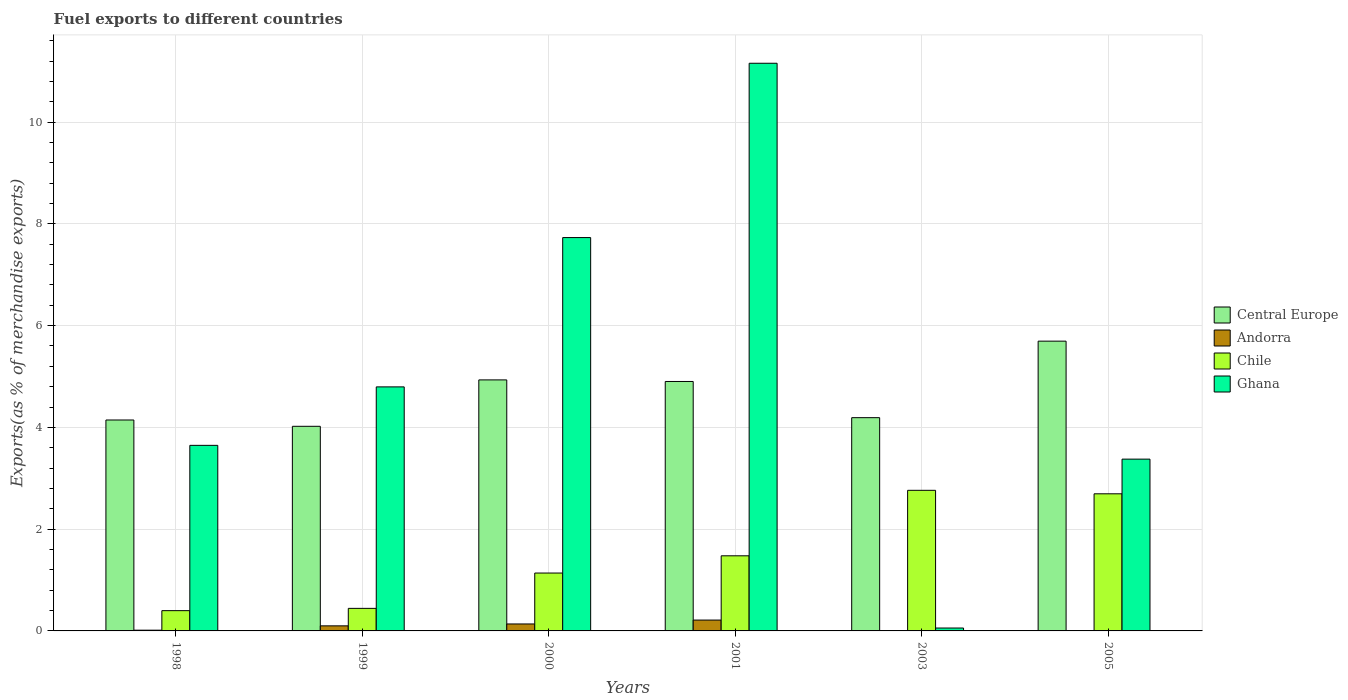How many different coloured bars are there?
Provide a short and direct response. 4. What is the label of the 2nd group of bars from the left?
Your response must be concise. 1999. What is the percentage of exports to different countries in Ghana in 2000?
Provide a succinct answer. 7.73. Across all years, what is the maximum percentage of exports to different countries in Andorra?
Give a very brief answer. 0.21. Across all years, what is the minimum percentage of exports to different countries in Andorra?
Your answer should be compact. 0. In which year was the percentage of exports to different countries in Chile minimum?
Your answer should be very brief. 1998. What is the total percentage of exports to different countries in Andorra in the graph?
Provide a short and direct response. 0.47. What is the difference between the percentage of exports to different countries in Central Europe in 1998 and that in 2005?
Offer a terse response. -1.55. What is the difference between the percentage of exports to different countries in Andorra in 2005 and the percentage of exports to different countries in Central Europe in 1998?
Offer a very short reply. -4.14. What is the average percentage of exports to different countries in Chile per year?
Keep it short and to the point. 1.49. In the year 1998, what is the difference between the percentage of exports to different countries in Ghana and percentage of exports to different countries in Chile?
Provide a succinct answer. 3.25. In how many years, is the percentage of exports to different countries in Ghana greater than 8.8 %?
Keep it short and to the point. 1. What is the ratio of the percentage of exports to different countries in Andorra in 1998 to that in 2001?
Your answer should be compact. 0.07. What is the difference between the highest and the second highest percentage of exports to different countries in Chile?
Your answer should be compact. 0.07. What is the difference between the highest and the lowest percentage of exports to different countries in Andorra?
Your answer should be very brief. 0.21. Is the sum of the percentage of exports to different countries in Central Europe in 2000 and 2003 greater than the maximum percentage of exports to different countries in Andorra across all years?
Make the answer very short. Yes. What does the 1st bar from the left in 2001 represents?
Offer a terse response. Central Europe. What does the 4th bar from the right in 2005 represents?
Provide a short and direct response. Central Europe. How many bars are there?
Your answer should be compact. 24. Are the values on the major ticks of Y-axis written in scientific E-notation?
Your answer should be compact. No. Does the graph contain grids?
Provide a succinct answer. Yes. What is the title of the graph?
Keep it short and to the point. Fuel exports to different countries. What is the label or title of the X-axis?
Your answer should be very brief. Years. What is the label or title of the Y-axis?
Offer a terse response. Exports(as % of merchandise exports). What is the Exports(as % of merchandise exports) in Central Europe in 1998?
Give a very brief answer. 4.15. What is the Exports(as % of merchandise exports) of Andorra in 1998?
Provide a succinct answer. 0.01. What is the Exports(as % of merchandise exports) of Chile in 1998?
Your response must be concise. 0.4. What is the Exports(as % of merchandise exports) of Ghana in 1998?
Offer a very short reply. 3.65. What is the Exports(as % of merchandise exports) of Central Europe in 1999?
Make the answer very short. 4.02. What is the Exports(as % of merchandise exports) of Andorra in 1999?
Provide a succinct answer. 0.1. What is the Exports(as % of merchandise exports) of Chile in 1999?
Provide a succinct answer. 0.44. What is the Exports(as % of merchandise exports) of Ghana in 1999?
Provide a succinct answer. 4.8. What is the Exports(as % of merchandise exports) in Central Europe in 2000?
Give a very brief answer. 4.93. What is the Exports(as % of merchandise exports) of Andorra in 2000?
Give a very brief answer. 0.14. What is the Exports(as % of merchandise exports) of Chile in 2000?
Your answer should be very brief. 1.14. What is the Exports(as % of merchandise exports) of Ghana in 2000?
Give a very brief answer. 7.73. What is the Exports(as % of merchandise exports) of Central Europe in 2001?
Your answer should be very brief. 4.9. What is the Exports(as % of merchandise exports) in Andorra in 2001?
Provide a succinct answer. 0.21. What is the Exports(as % of merchandise exports) in Chile in 2001?
Offer a terse response. 1.48. What is the Exports(as % of merchandise exports) in Ghana in 2001?
Offer a very short reply. 11.16. What is the Exports(as % of merchandise exports) in Central Europe in 2003?
Provide a succinct answer. 4.19. What is the Exports(as % of merchandise exports) of Andorra in 2003?
Keep it short and to the point. 0.01. What is the Exports(as % of merchandise exports) of Chile in 2003?
Keep it short and to the point. 2.76. What is the Exports(as % of merchandise exports) of Ghana in 2003?
Give a very brief answer. 0.06. What is the Exports(as % of merchandise exports) of Central Europe in 2005?
Your answer should be very brief. 5.69. What is the Exports(as % of merchandise exports) in Andorra in 2005?
Your answer should be compact. 0. What is the Exports(as % of merchandise exports) in Chile in 2005?
Your response must be concise. 2.69. What is the Exports(as % of merchandise exports) of Ghana in 2005?
Offer a very short reply. 3.38. Across all years, what is the maximum Exports(as % of merchandise exports) in Central Europe?
Your answer should be compact. 5.69. Across all years, what is the maximum Exports(as % of merchandise exports) of Andorra?
Provide a short and direct response. 0.21. Across all years, what is the maximum Exports(as % of merchandise exports) of Chile?
Your response must be concise. 2.76. Across all years, what is the maximum Exports(as % of merchandise exports) in Ghana?
Offer a very short reply. 11.16. Across all years, what is the minimum Exports(as % of merchandise exports) of Central Europe?
Keep it short and to the point. 4.02. Across all years, what is the minimum Exports(as % of merchandise exports) in Andorra?
Give a very brief answer. 0. Across all years, what is the minimum Exports(as % of merchandise exports) of Chile?
Your answer should be very brief. 0.4. Across all years, what is the minimum Exports(as % of merchandise exports) in Ghana?
Your response must be concise. 0.06. What is the total Exports(as % of merchandise exports) of Central Europe in the graph?
Provide a short and direct response. 27.89. What is the total Exports(as % of merchandise exports) of Andorra in the graph?
Give a very brief answer. 0.47. What is the total Exports(as % of merchandise exports) in Chile in the graph?
Keep it short and to the point. 8.91. What is the total Exports(as % of merchandise exports) of Ghana in the graph?
Make the answer very short. 30.76. What is the difference between the Exports(as % of merchandise exports) of Central Europe in 1998 and that in 1999?
Offer a terse response. 0.12. What is the difference between the Exports(as % of merchandise exports) in Andorra in 1998 and that in 1999?
Ensure brevity in your answer.  -0.09. What is the difference between the Exports(as % of merchandise exports) of Chile in 1998 and that in 1999?
Make the answer very short. -0.04. What is the difference between the Exports(as % of merchandise exports) of Ghana in 1998 and that in 1999?
Your answer should be very brief. -1.15. What is the difference between the Exports(as % of merchandise exports) in Central Europe in 1998 and that in 2000?
Offer a terse response. -0.79. What is the difference between the Exports(as % of merchandise exports) in Andorra in 1998 and that in 2000?
Provide a short and direct response. -0.12. What is the difference between the Exports(as % of merchandise exports) of Chile in 1998 and that in 2000?
Provide a short and direct response. -0.74. What is the difference between the Exports(as % of merchandise exports) in Ghana in 1998 and that in 2000?
Your answer should be very brief. -4.08. What is the difference between the Exports(as % of merchandise exports) of Central Europe in 1998 and that in 2001?
Provide a succinct answer. -0.76. What is the difference between the Exports(as % of merchandise exports) of Andorra in 1998 and that in 2001?
Make the answer very short. -0.2. What is the difference between the Exports(as % of merchandise exports) of Chile in 1998 and that in 2001?
Keep it short and to the point. -1.08. What is the difference between the Exports(as % of merchandise exports) in Ghana in 1998 and that in 2001?
Give a very brief answer. -7.51. What is the difference between the Exports(as % of merchandise exports) of Central Europe in 1998 and that in 2003?
Ensure brevity in your answer.  -0.05. What is the difference between the Exports(as % of merchandise exports) in Andorra in 1998 and that in 2003?
Your response must be concise. 0.01. What is the difference between the Exports(as % of merchandise exports) in Chile in 1998 and that in 2003?
Provide a short and direct response. -2.36. What is the difference between the Exports(as % of merchandise exports) in Ghana in 1998 and that in 2003?
Ensure brevity in your answer.  3.59. What is the difference between the Exports(as % of merchandise exports) in Central Europe in 1998 and that in 2005?
Offer a very short reply. -1.55. What is the difference between the Exports(as % of merchandise exports) in Andorra in 1998 and that in 2005?
Make the answer very short. 0.01. What is the difference between the Exports(as % of merchandise exports) of Chile in 1998 and that in 2005?
Your response must be concise. -2.3. What is the difference between the Exports(as % of merchandise exports) of Ghana in 1998 and that in 2005?
Keep it short and to the point. 0.27. What is the difference between the Exports(as % of merchandise exports) in Central Europe in 1999 and that in 2000?
Your response must be concise. -0.91. What is the difference between the Exports(as % of merchandise exports) of Andorra in 1999 and that in 2000?
Offer a terse response. -0.04. What is the difference between the Exports(as % of merchandise exports) of Chile in 1999 and that in 2000?
Your answer should be very brief. -0.69. What is the difference between the Exports(as % of merchandise exports) of Ghana in 1999 and that in 2000?
Your answer should be compact. -2.93. What is the difference between the Exports(as % of merchandise exports) of Central Europe in 1999 and that in 2001?
Your answer should be compact. -0.88. What is the difference between the Exports(as % of merchandise exports) in Andorra in 1999 and that in 2001?
Your answer should be very brief. -0.11. What is the difference between the Exports(as % of merchandise exports) in Chile in 1999 and that in 2001?
Provide a short and direct response. -1.03. What is the difference between the Exports(as % of merchandise exports) of Ghana in 1999 and that in 2001?
Keep it short and to the point. -6.36. What is the difference between the Exports(as % of merchandise exports) in Central Europe in 1999 and that in 2003?
Provide a succinct answer. -0.17. What is the difference between the Exports(as % of merchandise exports) of Andorra in 1999 and that in 2003?
Give a very brief answer. 0.09. What is the difference between the Exports(as % of merchandise exports) in Chile in 1999 and that in 2003?
Offer a terse response. -2.32. What is the difference between the Exports(as % of merchandise exports) in Ghana in 1999 and that in 2003?
Your answer should be compact. 4.74. What is the difference between the Exports(as % of merchandise exports) of Central Europe in 1999 and that in 2005?
Ensure brevity in your answer.  -1.67. What is the difference between the Exports(as % of merchandise exports) in Andorra in 1999 and that in 2005?
Offer a very short reply. 0.1. What is the difference between the Exports(as % of merchandise exports) in Chile in 1999 and that in 2005?
Provide a succinct answer. -2.25. What is the difference between the Exports(as % of merchandise exports) in Ghana in 1999 and that in 2005?
Provide a succinct answer. 1.42. What is the difference between the Exports(as % of merchandise exports) of Central Europe in 2000 and that in 2001?
Your response must be concise. 0.03. What is the difference between the Exports(as % of merchandise exports) in Andorra in 2000 and that in 2001?
Ensure brevity in your answer.  -0.08. What is the difference between the Exports(as % of merchandise exports) of Chile in 2000 and that in 2001?
Keep it short and to the point. -0.34. What is the difference between the Exports(as % of merchandise exports) of Ghana in 2000 and that in 2001?
Offer a very short reply. -3.43. What is the difference between the Exports(as % of merchandise exports) of Central Europe in 2000 and that in 2003?
Offer a very short reply. 0.74. What is the difference between the Exports(as % of merchandise exports) of Andorra in 2000 and that in 2003?
Ensure brevity in your answer.  0.13. What is the difference between the Exports(as % of merchandise exports) of Chile in 2000 and that in 2003?
Provide a short and direct response. -1.63. What is the difference between the Exports(as % of merchandise exports) of Ghana in 2000 and that in 2003?
Provide a short and direct response. 7.67. What is the difference between the Exports(as % of merchandise exports) of Central Europe in 2000 and that in 2005?
Your answer should be compact. -0.76. What is the difference between the Exports(as % of merchandise exports) in Andorra in 2000 and that in 2005?
Make the answer very short. 0.13. What is the difference between the Exports(as % of merchandise exports) in Chile in 2000 and that in 2005?
Offer a terse response. -1.56. What is the difference between the Exports(as % of merchandise exports) of Ghana in 2000 and that in 2005?
Give a very brief answer. 4.35. What is the difference between the Exports(as % of merchandise exports) in Central Europe in 2001 and that in 2003?
Your answer should be compact. 0.71. What is the difference between the Exports(as % of merchandise exports) of Andorra in 2001 and that in 2003?
Provide a short and direct response. 0.21. What is the difference between the Exports(as % of merchandise exports) in Chile in 2001 and that in 2003?
Offer a terse response. -1.29. What is the difference between the Exports(as % of merchandise exports) in Ghana in 2001 and that in 2003?
Provide a short and direct response. 11.1. What is the difference between the Exports(as % of merchandise exports) in Central Europe in 2001 and that in 2005?
Give a very brief answer. -0.79. What is the difference between the Exports(as % of merchandise exports) in Andorra in 2001 and that in 2005?
Keep it short and to the point. 0.21. What is the difference between the Exports(as % of merchandise exports) in Chile in 2001 and that in 2005?
Your answer should be compact. -1.22. What is the difference between the Exports(as % of merchandise exports) of Ghana in 2001 and that in 2005?
Offer a terse response. 7.78. What is the difference between the Exports(as % of merchandise exports) in Central Europe in 2003 and that in 2005?
Offer a terse response. -1.5. What is the difference between the Exports(as % of merchandise exports) in Andorra in 2003 and that in 2005?
Provide a short and direct response. 0. What is the difference between the Exports(as % of merchandise exports) of Chile in 2003 and that in 2005?
Keep it short and to the point. 0.07. What is the difference between the Exports(as % of merchandise exports) in Ghana in 2003 and that in 2005?
Provide a succinct answer. -3.32. What is the difference between the Exports(as % of merchandise exports) in Central Europe in 1998 and the Exports(as % of merchandise exports) in Andorra in 1999?
Offer a very short reply. 4.05. What is the difference between the Exports(as % of merchandise exports) in Central Europe in 1998 and the Exports(as % of merchandise exports) in Chile in 1999?
Provide a short and direct response. 3.7. What is the difference between the Exports(as % of merchandise exports) of Central Europe in 1998 and the Exports(as % of merchandise exports) of Ghana in 1999?
Provide a succinct answer. -0.65. What is the difference between the Exports(as % of merchandise exports) in Andorra in 1998 and the Exports(as % of merchandise exports) in Chile in 1999?
Your answer should be very brief. -0.43. What is the difference between the Exports(as % of merchandise exports) in Andorra in 1998 and the Exports(as % of merchandise exports) in Ghana in 1999?
Provide a succinct answer. -4.78. What is the difference between the Exports(as % of merchandise exports) of Chile in 1998 and the Exports(as % of merchandise exports) of Ghana in 1999?
Make the answer very short. -4.4. What is the difference between the Exports(as % of merchandise exports) in Central Europe in 1998 and the Exports(as % of merchandise exports) in Andorra in 2000?
Make the answer very short. 4.01. What is the difference between the Exports(as % of merchandise exports) of Central Europe in 1998 and the Exports(as % of merchandise exports) of Chile in 2000?
Your answer should be very brief. 3.01. What is the difference between the Exports(as % of merchandise exports) of Central Europe in 1998 and the Exports(as % of merchandise exports) of Ghana in 2000?
Your answer should be compact. -3.58. What is the difference between the Exports(as % of merchandise exports) of Andorra in 1998 and the Exports(as % of merchandise exports) of Chile in 2000?
Keep it short and to the point. -1.12. What is the difference between the Exports(as % of merchandise exports) of Andorra in 1998 and the Exports(as % of merchandise exports) of Ghana in 2000?
Offer a very short reply. -7.72. What is the difference between the Exports(as % of merchandise exports) of Chile in 1998 and the Exports(as % of merchandise exports) of Ghana in 2000?
Give a very brief answer. -7.33. What is the difference between the Exports(as % of merchandise exports) of Central Europe in 1998 and the Exports(as % of merchandise exports) of Andorra in 2001?
Offer a terse response. 3.93. What is the difference between the Exports(as % of merchandise exports) of Central Europe in 1998 and the Exports(as % of merchandise exports) of Chile in 2001?
Give a very brief answer. 2.67. What is the difference between the Exports(as % of merchandise exports) in Central Europe in 1998 and the Exports(as % of merchandise exports) in Ghana in 2001?
Offer a very short reply. -7.01. What is the difference between the Exports(as % of merchandise exports) of Andorra in 1998 and the Exports(as % of merchandise exports) of Chile in 2001?
Give a very brief answer. -1.46. What is the difference between the Exports(as % of merchandise exports) of Andorra in 1998 and the Exports(as % of merchandise exports) of Ghana in 2001?
Ensure brevity in your answer.  -11.14. What is the difference between the Exports(as % of merchandise exports) in Chile in 1998 and the Exports(as % of merchandise exports) in Ghana in 2001?
Your answer should be very brief. -10.76. What is the difference between the Exports(as % of merchandise exports) of Central Europe in 1998 and the Exports(as % of merchandise exports) of Andorra in 2003?
Ensure brevity in your answer.  4.14. What is the difference between the Exports(as % of merchandise exports) of Central Europe in 1998 and the Exports(as % of merchandise exports) of Chile in 2003?
Provide a short and direct response. 1.38. What is the difference between the Exports(as % of merchandise exports) of Central Europe in 1998 and the Exports(as % of merchandise exports) of Ghana in 2003?
Make the answer very short. 4.09. What is the difference between the Exports(as % of merchandise exports) of Andorra in 1998 and the Exports(as % of merchandise exports) of Chile in 2003?
Your answer should be very brief. -2.75. What is the difference between the Exports(as % of merchandise exports) in Andorra in 1998 and the Exports(as % of merchandise exports) in Ghana in 2003?
Your answer should be very brief. -0.04. What is the difference between the Exports(as % of merchandise exports) in Chile in 1998 and the Exports(as % of merchandise exports) in Ghana in 2003?
Your answer should be compact. 0.34. What is the difference between the Exports(as % of merchandise exports) of Central Europe in 1998 and the Exports(as % of merchandise exports) of Andorra in 2005?
Your answer should be very brief. 4.14. What is the difference between the Exports(as % of merchandise exports) in Central Europe in 1998 and the Exports(as % of merchandise exports) in Chile in 2005?
Offer a terse response. 1.45. What is the difference between the Exports(as % of merchandise exports) of Central Europe in 1998 and the Exports(as % of merchandise exports) of Ghana in 2005?
Your answer should be very brief. 0.77. What is the difference between the Exports(as % of merchandise exports) in Andorra in 1998 and the Exports(as % of merchandise exports) in Chile in 2005?
Ensure brevity in your answer.  -2.68. What is the difference between the Exports(as % of merchandise exports) of Andorra in 1998 and the Exports(as % of merchandise exports) of Ghana in 2005?
Keep it short and to the point. -3.36. What is the difference between the Exports(as % of merchandise exports) of Chile in 1998 and the Exports(as % of merchandise exports) of Ghana in 2005?
Make the answer very short. -2.98. What is the difference between the Exports(as % of merchandise exports) in Central Europe in 1999 and the Exports(as % of merchandise exports) in Andorra in 2000?
Offer a terse response. 3.88. What is the difference between the Exports(as % of merchandise exports) of Central Europe in 1999 and the Exports(as % of merchandise exports) of Chile in 2000?
Make the answer very short. 2.88. What is the difference between the Exports(as % of merchandise exports) of Central Europe in 1999 and the Exports(as % of merchandise exports) of Ghana in 2000?
Offer a very short reply. -3.71. What is the difference between the Exports(as % of merchandise exports) in Andorra in 1999 and the Exports(as % of merchandise exports) in Chile in 2000?
Provide a short and direct response. -1.04. What is the difference between the Exports(as % of merchandise exports) of Andorra in 1999 and the Exports(as % of merchandise exports) of Ghana in 2000?
Your response must be concise. -7.63. What is the difference between the Exports(as % of merchandise exports) in Chile in 1999 and the Exports(as % of merchandise exports) in Ghana in 2000?
Provide a short and direct response. -7.29. What is the difference between the Exports(as % of merchandise exports) in Central Europe in 1999 and the Exports(as % of merchandise exports) in Andorra in 2001?
Your response must be concise. 3.81. What is the difference between the Exports(as % of merchandise exports) of Central Europe in 1999 and the Exports(as % of merchandise exports) of Chile in 2001?
Your answer should be very brief. 2.54. What is the difference between the Exports(as % of merchandise exports) of Central Europe in 1999 and the Exports(as % of merchandise exports) of Ghana in 2001?
Your answer should be compact. -7.13. What is the difference between the Exports(as % of merchandise exports) in Andorra in 1999 and the Exports(as % of merchandise exports) in Chile in 2001?
Your answer should be compact. -1.38. What is the difference between the Exports(as % of merchandise exports) in Andorra in 1999 and the Exports(as % of merchandise exports) in Ghana in 2001?
Give a very brief answer. -11.06. What is the difference between the Exports(as % of merchandise exports) of Chile in 1999 and the Exports(as % of merchandise exports) of Ghana in 2001?
Provide a succinct answer. -10.71. What is the difference between the Exports(as % of merchandise exports) in Central Europe in 1999 and the Exports(as % of merchandise exports) in Andorra in 2003?
Offer a very short reply. 4.01. What is the difference between the Exports(as % of merchandise exports) in Central Europe in 1999 and the Exports(as % of merchandise exports) in Chile in 2003?
Provide a succinct answer. 1.26. What is the difference between the Exports(as % of merchandise exports) of Central Europe in 1999 and the Exports(as % of merchandise exports) of Ghana in 2003?
Ensure brevity in your answer.  3.96. What is the difference between the Exports(as % of merchandise exports) of Andorra in 1999 and the Exports(as % of merchandise exports) of Chile in 2003?
Keep it short and to the point. -2.66. What is the difference between the Exports(as % of merchandise exports) of Andorra in 1999 and the Exports(as % of merchandise exports) of Ghana in 2003?
Your response must be concise. 0.04. What is the difference between the Exports(as % of merchandise exports) in Chile in 1999 and the Exports(as % of merchandise exports) in Ghana in 2003?
Your answer should be compact. 0.39. What is the difference between the Exports(as % of merchandise exports) in Central Europe in 1999 and the Exports(as % of merchandise exports) in Andorra in 2005?
Your response must be concise. 4.02. What is the difference between the Exports(as % of merchandise exports) in Central Europe in 1999 and the Exports(as % of merchandise exports) in Chile in 2005?
Your response must be concise. 1.33. What is the difference between the Exports(as % of merchandise exports) of Central Europe in 1999 and the Exports(as % of merchandise exports) of Ghana in 2005?
Ensure brevity in your answer.  0.65. What is the difference between the Exports(as % of merchandise exports) in Andorra in 1999 and the Exports(as % of merchandise exports) in Chile in 2005?
Your answer should be very brief. -2.6. What is the difference between the Exports(as % of merchandise exports) in Andorra in 1999 and the Exports(as % of merchandise exports) in Ghana in 2005?
Your answer should be very brief. -3.28. What is the difference between the Exports(as % of merchandise exports) in Chile in 1999 and the Exports(as % of merchandise exports) in Ghana in 2005?
Offer a very short reply. -2.93. What is the difference between the Exports(as % of merchandise exports) of Central Europe in 2000 and the Exports(as % of merchandise exports) of Andorra in 2001?
Make the answer very short. 4.72. What is the difference between the Exports(as % of merchandise exports) in Central Europe in 2000 and the Exports(as % of merchandise exports) in Chile in 2001?
Your answer should be compact. 3.46. What is the difference between the Exports(as % of merchandise exports) in Central Europe in 2000 and the Exports(as % of merchandise exports) in Ghana in 2001?
Keep it short and to the point. -6.22. What is the difference between the Exports(as % of merchandise exports) of Andorra in 2000 and the Exports(as % of merchandise exports) of Chile in 2001?
Your answer should be very brief. -1.34. What is the difference between the Exports(as % of merchandise exports) in Andorra in 2000 and the Exports(as % of merchandise exports) in Ghana in 2001?
Give a very brief answer. -11.02. What is the difference between the Exports(as % of merchandise exports) in Chile in 2000 and the Exports(as % of merchandise exports) in Ghana in 2001?
Offer a terse response. -10.02. What is the difference between the Exports(as % of merchandise exports) of Central Europe in 2000 and the Exports(as % of merchandise exports) of Andorra in 2003?
Offer a terse response. 4.93. What is the difference between the Exports(as % of merchandise exports) in Central Europe in 2000 and the Exports(as % of merchandise exports) in Chile in 2003?
Your answer should be compact. 2.17. What is the difference between the Exports(as % of merchandise exports) of Central Europe in 2000 and the Exports(as % of merchandise exports) of Ghana in 2003?
Offer a terse response. 4.88. What is the difference between the Exports(as % of merchandise exports) in Andorra in 2000 and the Exports(as % of merchandise exports) in Chile in 2003?
Keep it short and to the point. -2.63. What is the difference between the Exports(as % of merchandise exports) in Andorra in 2000 and the Exports(as % of merchandise exports) in Ghana in 2003?
Your response must be concise. 0.08. What is the difference between the Exports(as % of merchandise exports) of Chile in 2000 and the Exports(as % of merchandise exports) of Ghana in 2003?
Provide a short and direct response. 1.08. What is the difference between the Exports(as % of merchandise exports) in Central Europe in 2000 and the Exports(as % of merchandise exports) in Andorra in 2005?
Offer a very short reply. 4.93. What is the difference between the Exports(as % of merchandise exports) in Central Europe in 2000 and the Exports(as % of merchandise exports) in Chile in 2005?
Offer a very short reply. 2.24. What is the difference between the Exports(as % of merchandise exports) of Central Europe in 2000 and the Exports(as % of merchandise exports) of Ghana in 2005?
Provide a short and direct response. 1.56. What is the difference between the Exports(as % of merchandise exports) of Andorra in 2000 and the Exports(as % of merchandise exports) of Chile in 2005?
Your answer should be compact. -2.56. What is the difference between the Exports(as % of merchandise exports) of Andorra in 2000 and the Exports(as % of merchandise exports) of Ghana in 2005?
Your response must be concise. -3.24. What is the difference between the Exports(as % of merchandise exports) in Chile in 2000 and the Exports(as % of merchandise exports) in Ghana in 2005?
Your response must be concise. -2.24. What is the difference between the Exports(as % of merchandise exports) in Central Europe in 2001 and the Exports(as % of merchandise exports) in Andorra in 2003?
Provide a succinct answer. 4.9. What is the difference between the Exports(as % of merchandise exports) of Central Europe in 2001 and the Exports(as % of merchandise exports) of Chile in 2003?
Your answer should be compact. 2.14. What is the difference between the Exports(as % of merchandise exports) in Central Europe in 2001 and the Exports(as % of merchandise exports) in Ghana in 2003?
Keep it short and to the point. 4.85. What is the difference between the Exports(as % of merchandise exports) of Andorra in 2001 and the Exports(as % of merchandise exports) of Chile in 2003?
Ensure brevity in your answer.  -2.55. What is the difference between the Exports(as % of merchandise exports) of Andorra in 2001 and the Exports(as % of merchandise exports) of Ghana in 2003?
Your response must be concise. 0.16. What is the difference between the Exports(as % of merchandise exports) in Chile in 2001 and the Exports(as % of merchandise exports) in Ghana in 2003?
Give a very brief answer. 1.42. What is the difference between the Exports(as % of merchandise exports) in Central Europe in 2001 and the Exports(as % of merchandise exports) in Andorra in 2005?
Offer a terse response. 4.9. What is the difference between the Exports(as % of merchandise exports) in Central Europe in 2001 and the Exports(as % of merchandise exports) in Chile in 2005?
Give a very brief answer. 2.21. What is the difference between the Exports(as % of merchandise exports) of Central Europe in 2001 and the Exports(as % of merchandise exports) of Ghana in 2005?
Offer a very short reply. 1.53. What is the difference between the Exports(as % of merchandise exports) of Andorra in 2001 and the Exports(as % of merchandise exports) of Chile in 2005?
Provide a succinct answer. -2.48. What is the difference between the Exports(as % of merchandise exports) in Andorra in 2001 and the Exports(as % of merchandise exports) in Ghana in 2005?
Your answer should be compact. -3.16. What is the difference between the Exports(as % of merchandise exports) in Chile in 2001 and the Exports(as % of merchandise exports) in Ghana in 2005?
Offer a very short reply. -1.9. What is the difference between the Exports(as % of merchandise exports) in Central Europe in 2003 and the Exports(as % of merchandise exports) in Andorra in 2005?
Your response must be concise. 4.19. What is the difference between the Exports(as % of merchandise exports) of Central Europe in 2003 and the Exports(as % of merchandise exports) of Chile in 2005?
Provide a short and direct response. 1.5. What is the difference between the Exports(as % of merchandise exports) in Central Europe in 2003 and the Exports(as % of merchandise exports) in Ghana in 2005?
Your answer should be very brief. 0.81. What is the difference between the Exports(as % of merchandise exports) in Andorra in 2003 and the Exports(as % of merchandise exports) in Chile in 2005?
Your response must be concise. -2.69. What is the difference between the Exports(as % of merchandise exports) in Andorra in 2003 and the Exports(as % of merchandise exports) in Ghana in 2005?
Your response must be concise. -3.37. What is the difference between the Exports(as % of merchandise exports) of Chile in 2003 and the Exports(as % of merchandise exports) of Ghana in 2005?
Make the answer very short. -0.61. What is the average Exports(as % of merchandise exports) in Central Europe per year?
Offer a terse response. 4.65. What is the average Exports(as % of merchandise exports) of Andorra per year?
Provide a short and direct response. 0.08. What is the average Exports(as % of merchandise exports) in Chile per year?
Make the answer very short. 1.49. What is the average Exports(as % of merchandise exports) of Ghana per year?
Ensure brevity in your answer.  5.13. In the year 1998, what is the difference between the Exports(as % of merchandise exports) of Central Europe and Exports(as % of merchandise exports) of Andorra?
Provide a succinct answer. 4.13. In the year 1998, what is the difference between the Exports(as % of merchandise exports) of Central Europe and Exports(as % of merchandise exports) of Chile?
Offer a very short reply. 3.75. In the year 1998, what is the difference between the Exports(as % of merchandise exports) in Central Europe and Exports(as % of merchandise exports) in Ghana?
Make the answer very short. 0.5. In the year 1998, what is the difference between the Exports(as % of merchandise exports) in Andorra and Exports(as % of merchandise exports) in Chile?
Your answer should be compact. -0.38. In the year 1998, what is the difference between the Exports(as % of merchandise exports) of Andorra and Exports(as % of merchandise exports) of Ghana?
Provide a succinct answer. -3.63. In the year 1998, what is the difference between the Exports(as % of merchandise exports) of Chile and Exports(as % of merchandise exports) of Ghana?
Offer a terse response. -3.25. In the year 1999, what is the difference between the Exports(as % of merchandise exports) of Central Europe and Exports(as % of merchandise exports) of Andorra?
Your response must be concise. 3.92. In the year 1999, what is the difference between the Exports(as % of merchandise exports) of Central Europe and Exports(as % of merchandise exports) of Chile?
Your answer should be compact. 3.58. In the year 1999, what is the difference between the Exports(as % of merchandise exports) in Central Europe and Exports(as % of merchandise exports) in Ghana?
Provide a succinct answer. -0.77. In the year 1999, what is the difference between the Exports(as % of merchandise exports) in Andorra and Exports(as % of merchandise exports) in Chile?
Ensure brevity in your answer.  -0.34. In the year 1999, what is the difference between the Exports(as % of merchandise exports) in Andorra and Exports(as % of merchandise exports) in Ghana?
Keep it short and to the point. -4.7. In the year 1999, what is the difference between the Exports(as % of merchandise exports) in Chile and Exports(as % of merchandise exports) in Ghana?
Your response must be concise. -4.35. In the year 2000, what is the difference between the Exports(as % of merchandise exports) in Central Europe and Exports(as % of merchandise exports) in Andorra?
Your response must be concise. 4.8. In the year 2000, what is the difference between the Exports(as % of merchandise exports) of Central Europe and Exports(as % of merchandise exports) of Chile?
Keep it short and to the point. 3.8. In the year 2000, what is the difference between the Exports(as % of merchandise exports) of Central Europe and Exports(as % of merchandise exports) of Ghana?
Ensure brevity in your answer.  -2.8. In the year 2000, what is the difference between the Exports(as % of merchandise exports) of Andorra and Exports(as % of merchandise exports) of Chile?
Provide a succinct answer. -1. In the year 2000, what is the difference between the Exports(as % of merchandise exports) in Andorra and Exports(as % of merchandise exports) in Ghana?
Offer a very short reply. -7.59. In the year 2000, what is the difference between the Exports(as % of merchandise exports) of Chile and Exports(as % of merchandise exports) of Ghana?
Provide a succinct answer. -6.59. In the year 2001, what is the difference between the Exports(as % of merchandise exports) in Central Europe and Exports(as % of merchandise exports) in Andorra?
Make the answer very short. 4.69. In the year 2001, what is the difference between the Exports(as % of merchandise exports) in Central Europe and Exports(as % of merchandise exports) in Chile?
Provide a short and direct response. 3.43. In the year 2001, what is the difference between the Exports(as % of merchandise exports) of Central Europe and Exports(as % of merchandise exports) of Ghana?
Offer a very short reply. -6.25. In the year 2001, what is the difference between the Exports(as % of merchandise exports) in Andorra and Exports(as % of merchandise exports) in Chile?
Make the answer very short. -1.26. In the year 2001, what is the difference between the Exports(as % of merchandise exports) of Andorra and Exports(as % of merchandise exports) of Ghana?
Make the answer very short. -10.94. In the year 2001, what is the difference between the Exports(as % of merchandise exports) in Chile and Exports(as % of merchandise exports) in Ghana?
Offer a very short reply. -9.68. In the year 2003, what is the difference between the Exports(as % of merchandise exports) in Central Europe and Exports(as % of merchandise exports) in Andorra?
Provide a succinct answer. 4.18. In the year 2003, what is the difference between the Exports(as % of merchandise exports) of Central Europe and Exports(as % of merchandise exports) of Chile?
Offer a very short reply. 1.43. In the year 2003, what is the difference between the Exports(as % of merchandise exports) of Central Europe and Exports(as % of merchandise exports) of Ghana?
Make the answer very short. 4.13. In the year 2003, what is the difference between the Exports(as % of merchandise exports) of Andorra and Exports(as % of merchandise exports) of Chile?
Your response must be concise. -2.76. In the year 2003, what is the difference between the Exports(as % of merchandise exports) of Andorra and Exports(as % of merchandise exports) of Ghana?
Keep it short and to the point. -0.05. In the year 2003, what is the difference between the Exports(as % of merchandise exports) of Chile and Exports(as % of merchandise exports) of Ghana?
Give a very brief answer. 2.71. In the year 2005, what is the difference between the Exports(as % of merchandise exports) of Central Europe and Exports(as % of merchandise exports) of Andorra?
Provide a succinct answer. 5.69. In the year 2005, what is the difference between the Exports(as % of merchandise exports) in Central Europe and Exports(as % of merchandise exports) in Chile?
Offer a very short reply. 3. In the year 2005, what is the difference between the Exports(as % of merchandise exports) in Central Europe and Exports(as % of merchandise exports) in Ghana?
Provide a succinct answer. 2.32. In the year 2005, what is the difference between the Exports(as % of merchandise exports) in Andorra and Exports(as % of merchandise exports) in Chile?
Your answer should be very brief. -2.69. In the year 2005, what is the difference between the Exports(as % of merchandise exports) in Andorra and Exports(as % of merchandise exports) in Ghana?
Ensure brevity in your answer.  -3.37. In the year 2005, what is the difference between the Exports(as % of merchandise exports) in Chile and Exports(as % of merchandise exports) in Ghana?
Keep it short and to the point. -0.68. What is the ratio of the Exports(as % of merchandise exports) in Central Europe in 1998 to that in 1999?
Your answer should be compact. 1.03. What is the ratio of the Exports(as % of merchandise exports) of Andorra in 1998 to that in 1999?
Your answer should be compact. 0.15. What is the ratio of the Exports(as % of merchandise exports) of Chile in 1998 to that in 1999?
Provide a short and direct response. 0.9. What is the ratio of the Exports(as % of merchandise exports) in Ghana in 1998 to that in 1999?
Provide a succinct answer. 0.76. What is the ratio of the Exports(as % of merchandise exports) in Central Europe in 1998 to that in 2000?
Provide a short and direct response. 0.84. What is the ratio of the Exports(as % of merchandise exports) of Andorra in 1998 to that in 2000?
Provide a short and direct response. 0.11. What is the ratio of the Exports(as % of merchandise exports) in Chile in 1998 to that in 2000?
Your answer should be compact. 0.35. What is the ratio of the Exports(as % of merchandise exports) of Ghana in 1998 to that in 2000?
Give a very brief answer. 0.47. What is the ratio of the Exports(as % of merchandise exports) in Central Europe in 1998 to that in 2001?
Your answer should be compact. 0.85. What is the ratio of the Exports(as % of merchandise exports) of Andorra in 1998 to that in 2001?
Keep it short and to the point. 0.07. What is the ratio of the Exports(as % of merchandise exports) of Chile in 1998 to that in 2001?
Give a very brief answer. 0.27. What is the ratio of the Exports(as % of merchandise exports) of Ghana in 1998 to that in 2001?
Keep it short and to the point. 0.33. What is the ratio of the Exports(as % of merchandise exports) of Central Europe in 1998 to that in 2003?
Give a very brief answer. 0.99. What is the ratio of the Exports(as % of merchandise exports) of Andorra in 1998 to that in 2003?
Your response must be concise. 2.19. What is the ratio of the Exports(as % of merchandise exports) of Chile in 1998 to that in 2003?
Give a very brief answer. 0.14. What is the ratio of the Exports(as % of merchandise exports) in Ghana in 1998 to that in 2003?
Ensure brevity in your answer.  64.13. What is the ratio of the Exports(as % of merchandise exports) in Central Europe in 1998 to that in 2005?
Keep it short and to the point. 0.73. What is the ratio of the Exports(as % of merchandise exports) of Andorra in 1998 to that in 2005?
Ensure brevity in your answer.  7.3. What is the ratio of the Exports(as % of merchandise exports) in Chile in 1998 to that in 2005?
Keep it short and to the point. 0.15. What is the ratio of the Exports(as % of merchandise exports) of Ghana in 1998 to that in 2005?
Your answer should be very brief. 1.08. What is the ratio of the Exports(as % of merchandise exports) in Central Europe in 1999 to that in 2000?
Offer a very short reply. 0.82. What is the ratio of the Exports(as % of merchandise exports) of Andorra in 1999 to that in 2000?
Offer a very short reply. 0.73. What is the ratio of the Exports(as % of merchandise exports) of Chile in 1999 to that in 2000?
Keep it short and to the point. 0.39. What is the ratio of the Exports(as % of merchandise exports) of Ghana in 1999 to that in 2000?
Provide a short and direct response. 0.62. What is the ratio of the Exports(as % of merchandise exports) of Central Europe in 1999 to that in 2001?
Offer a terse response. 0.82. What is the ratio of the Exports(as % of merchandise exports) of Andorra in 1999 to that in 2001?
Provide a short and direct response. 0.47. What is the ratio of the Exports(as % of merchandise exports) of Chile in 1999 to that in 2001?
Provide a succinct answer. 0.3. What is the ratio of the Exports(as % of merchandise exports) in Ghana in 1999 to that in 2001?
Provide a succinct answer. 0.43. What is the ratio of the Exports(as % of merchandise exports) in Central Europe in 1999 to that in 2003?
Your answer should be very brief. 0.96. What is the ratio of the Exports(as % of merchandise exports) of Andorra in 1999 to that in 2003?
Ensure brevity in your answer.  15.06. What is the ratio of the Exports(as % of merchandise exports) in Chile in 1999 to that in 2003?
Your answer should be very brief. 0.16. What is the ratio of the Exports(as % of merchandise exports) of Ghana in 1999 to that in 2003?
Offer a terse response. 84.33. What is the ratio of the Exports(as % of merchandise exports) in Central Europe in 1999 to that in 2005?
Offer a terse response. 0.71. What is the ratio of the Exports(as % of merchandise exports) in Andorra in 1999 to that in 2005?
Keep it short and to the point. 50.27. What is the ratio of the Exports(as % of merchandise exports) in Chile in 1999 to that in 2005?
Ensure brevity in your answer.  0.16. What is the ratio of the Exports(as % of merchandise exports) in Ghana in 1999 to that in 2005?
Give a very brief answer. 1.42. What is the ratio of the Exports(as % of merchandise exports) in Central Europe in 2000 to that in 2001?
Provide a short and direct response. 1.01. What is the ratio of the Exports(as % of merchandise exports) of Andorra in 2000 to that in 2001?
Ensure brevity in your answer.  0.64. What is the ratio of the Exports(as % of merchandise exports) of Chile in 2000 to that in 2001?
Ensure brevity in your answer.  0.77. What is the ratio of the Exports(as % of merchandise exports) of Ghana in 2000 to that in 2001?
Provide a succinct answer. 0.69. What is the ratio of the Exports(as % of merchandise exports) of Central Europe in 2000 to that in 2003?
Your answer should be very brief. 1.18. What is the ratio of the Exports(as % of merchandise exports) in Andorra in 2000 to that in 2003?
Your answer should be very brief. 20.68. What is the ratio of the Exports(as % of merchandise exports) of Chile in 2000 to that in 2003?
Your response must be concise. 0.41. What is the ratio of the Exports(as % of merchandise exports) in Ghana in 2000 to that in 2003?
Offer a very short reply. 135.93. What is the ratio of the Exports(as % of merchandise exports) in Central Europe in 2000 to that in 2005?
Ensure brevity in your answer.  0.87. What is the ratio of the Exports(as % of merchandise exports) of Andorra in 2000 to that in 2005?
Ensure brevity in your answer.  69.07. What is the ratio of the Exports(as % of merchandise exports) of Chile in 2000 to that in 2005?
Keep it short and to the point. 0.42. What is the ratio of the Exports(as % of merchandise exports) in Ghana in 2000 to that in 2005?
Offer a very short reply. 2.29. What is the ratio of the Exports(as % of merchandise exports) in Central Europe in 2001 to that in 2003?
Provide a succinct answer. 1.17. What is the ratio of the Exports(as % of merchandise exports) of Andorra in 2001 to that in 2003?
Offer a terse response. 32.25. What is the ratio of the Exports(as % of merchandise exports) in Chile in 2001 to that in 2003?
Give a very brief answer. 0.53. What is the ratio of the Exports(as % of merchandise exports) in Ghana in 2001 to that in 2003?
Keep it short and to the point. 196.17. What is the ratio of the Exports(as % of merchandise exports) of Central Europe in 2001 to that in 2005?
Provide a short and direct response. 0.86. What is the ratio of the Exports(as % of merchandise exports) of Andorra in 2001 to that in 2005?
Make the answer very short. 107.68. What is the ratio of the Exports(as % of merchandise exports) of Chile in 2001 to that in 2005?
Ensure brevity in your answer.  0.55. What is the ratio of the Exports(as % of merchandise exports) of Ghana in 2001 to that in 2005?
Provide a succinct answer. 3.3. What is the ratio of the Exports(as % of merchandise exports) of Central Europe in 2003 to that in 2005?
Keep it short and to the point. 0.74. What is the ratio of the Exports(as % of merchandise exports) in Andorra in 2003 to that in 2005?
Provide a short and direct response. 3.34. What is the ratio of the Exports(as % of merchandise exports) in Chile in 2003 to that in 2005?
Your answer should be compact. 1.03. What is the ratio of the Exports(as % of merchandise exports) of Ghana in 2003 to that in 2005?
Give a very brief answer. 0.02. What is the difference between the highest and the second highest Exports(as % of merchandise exports) in Central Europe?
Offer a very short reply. 0.76. What is the difference between the highest and the second highest Exports(as % of merchandise exports) in Andorra?
Ensure brevity in your answer.  0.08. What is the difference between the highest and the second highest Exports(as % of merchandise exports) of Chile?
Offer a terse response. 0.07. What is the difference between the highest and the second highest Exports(as % of merchandise exports) in Ghana?
Offer a very short reply. 3.43. What is the difference between the highest and the lowest Exports(as % of merchandise exports) in Central Europe?
Offer a very short reply. 1.67. What is the difference between the highest and the lowest Exports(as % of merchandise exports) of Andorra?
Provide a succinct answer. 0.21. What is the difference between the highest and the lowest Exports(as % of merchandise exports) of Chile?
Provide a succinct answer. 2.36. What is the difference between the highest and the lowest Exports(as % of merchandise exports) in Ghana?
Your answer should be compact. 11.1. 